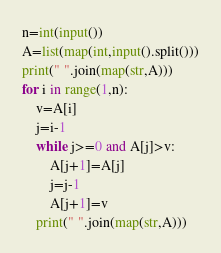Convert code to text. <code><loc_0><loc_0><loc_500><loc_500><_Python_>n=int(input())
A=list(map(int,input().split()))
print(" ".join(map(str,A)))
for i in range(1,n):
    v=A[i]
    j=i-1
    while j>=0 and A[j]>v:
        A[j+1]=A[j]
        j=j-1
        A[j+1]=v
    print(" ".join(map(str,A)))
</code> 